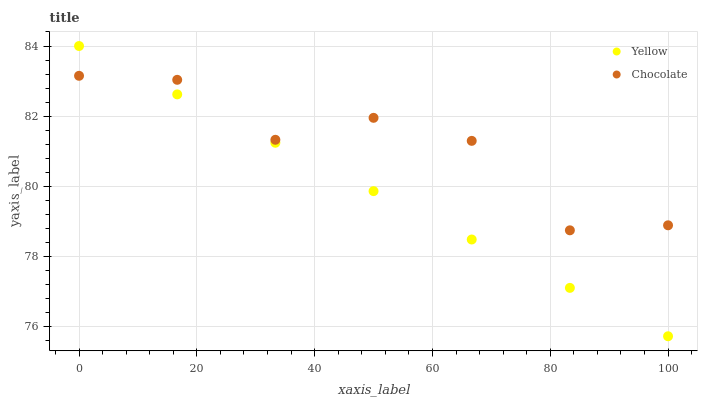Does Yellow have the minimum area under the curve?
Answer yes or no. Yes. Does Chocolate have the maximum area under the curve?
Answer yes or no. Yes. Does Chocolate have the minimum area under the curve?
Answer yes or no. No. Is Yellow the smoothest?
Answer yes or no. Yes. Is Chocolate the roughest?
Answer yes or no. Yes. Is Chocolate the smoothest?
Answer yes or no. No. Does Yellow have the lowest value?
Answer yes or no. Yes. Does Chocolate have the lowest value?
Answer yes or no. No. Does Yellow have the highest value?
Answer yes or no. Yes. Does Chocolate have the highest value?
Answer yes or no. No. Does Yellow intersect Chocolate?
Answer yes or no. Yes. Is Yellow less than Chocolate?
Answer yes or no. No. Is Yellow greater than Chocolate?
Answer yes or no. No. 